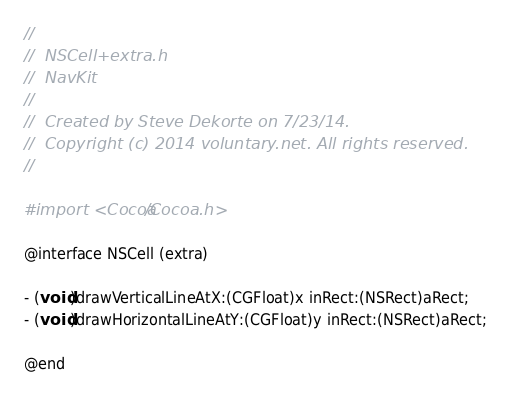Convert code to text. <code><loc_0><loc_0><loc_500><loc_500><_C_>//
//  NSCell+extra.h
//  NavKit
//
//  Created by Steve Dekorte on 7/23/14.
//  Copyright (c) 2014 voluntary.net. All rights reserved.
//

#import <Cocoa/Cocoa.h>

@interface NSCell (extra)

- (void)drawVerticalLineAtX:(CGFloat)x inRect:(NSRect)aRect;
- (void)drawHorizontalLineAtY:(CGFloat)y inRect:(NSRect)aRect;

@end
</code> 